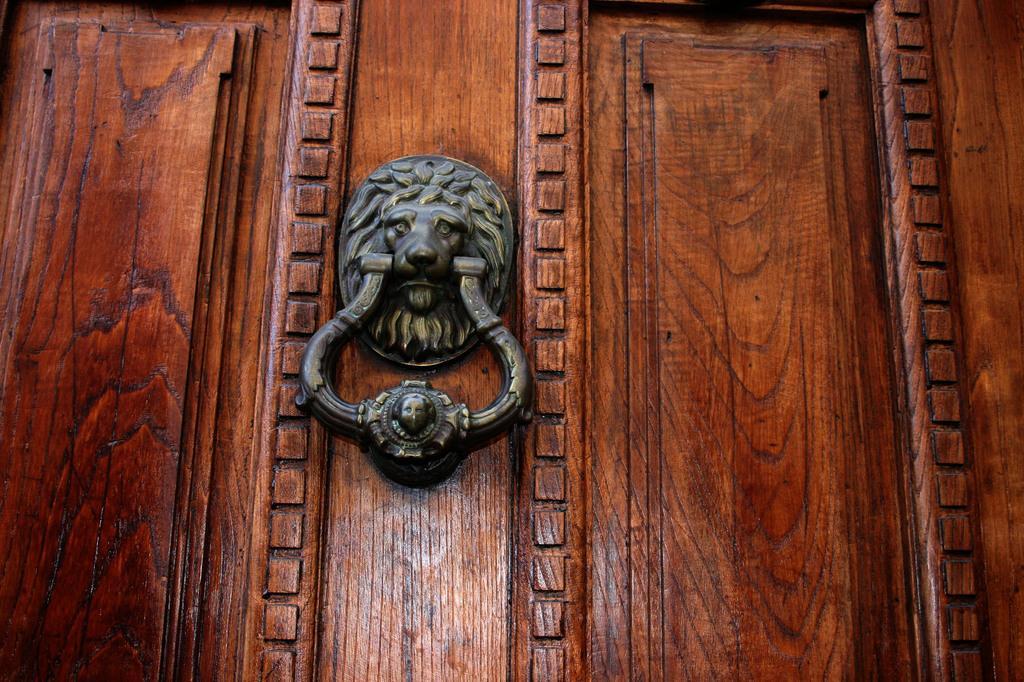Please provide a concise description of this image. In this image there is a copper tone lion head shaped door handle, which is attached to the door. 